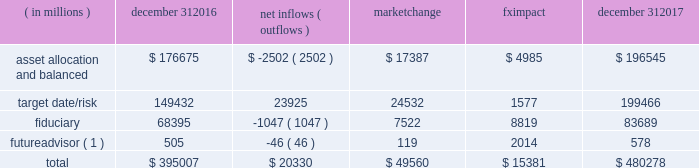Long-term product offerings include alpha-seeking active and index strategies .
Our alpha-seeking active strategies seek to earn attractive returns in excess of a market benchmark or performance hurdle while maintaining an appropriate risk profile , and leverage fundamental research and quantitative models to drive portfolio construction .
In contrast , index strategies seek to closely track the returns of a corresponding index , generally by investing in substantially the same underlying securities within the index or in a subset of those securities selected to approximate a similar risk and return profile of the index .
Index strategies include both our non-etf index products and ishares etfs .
Although many clients use both alpha-seeking active and index strategies , the application of these strategies may differ .
For example , clients may use index products to gain exposure to a market or asset class , or may use a combination of index strategies to target active returns .
In addition , institutional non-etf index assignments tend to be very large ( multi-billion dollars ) and typically reflect low fee rates .
Net flows in institutional index products generally have a small impact on blackrock 2019s revenues and earnings .
Equity year-end 2017 equity aum totaled $ 3.372 trillion , reflecting net inflows of $ 130.1 billion .
Net inflows included $ 174.4 billion into ishares etfs , driven by net inflows into core funds and broad developed and emerging market equities , partially offset by non-etf index and active net outflows of $ 25.7 billion and $ 18.5 billion , respectively .
Blackrock 2019s effective fee rates fluctuate due to changes in aum mix .
Approximately half of blackrock 2019s equity aum is tied to international markets , including emerging markets , which tend to have higher fee rates than u.s .
Equity strategies .
Accordingly , fluctuations in international equity markets , which may not consistently move in tandem with u.s .
Markets , have a greater impact on blackrock 2019s equity revenues and effective fee rate .
Fixed income fixed income aum ended 2017 at $ 1.855 trillion , reflecting net inflows of $ 178.8 billion .
In 2017 , active net inflows of $ 21.5 billion were diversified across fixed income offerings , and included strong inflows into municipal , unconstrained and total return bond funds .
Ishares etfs net inflows of $ 67.5 billion were led by flows into core , corporate and treasury bond funds .
Non-etf index net inflows of $ 89.8 billion were driven by demand for liability-driven investment solutions .
Multi-asset blackrock 2019s multi-asset team manages a variety of balanced funds and bespoke mandates for a diversified client base that leverages our broad investment expertise in global equities , bonds , currencies and commodities , and our extensive risk management capabilities .
Investment solutions might include a combination of long-only portfolios and alternative investments as well as tactical asset allocation overlays .
Component changes in multi-asset aum for 2017 are presented below .
( in millions ) december 31 , net inflows ( outflows ) market change impact december 31 .
( 1 ) futureadvisor amounts do not include aum held in ishares etfs .
Multi-asset net inflows reflected ongoing institutional demand for our solutions-based advice with $ 18.9 billion of net inflows coming from institutional clients .
Defined contribution plans of institutional clients remained a significant driver of flows , and contributed $ 20.8 billion to institutional multi-asset net inflows in 2017 , primarily into target date and target risk product offerings .
Retail net inflows of $ 1.1 billion reflected demand for our multi-asset income fund family , which raised $ 5.8 billion in 2017 .
The company 2019s multi-asset strategies include the following : 2022 asset allocation and balanced products represented 41% ( 41 % ) of multi-asset aum at year-end .
These strategies combine equity , fixed income and alternative components for investors seeking a tailored solution relative to a specific benchmark and within a risk budget .
In certain cases , these strategies seek to minimize downside risk through diversification , derivatives strategies and tactical asset allocation decisions .
Flagship products in this category include our global allocation and multi-asset income fund families .
2022 target date and target risk products grew 16% ( 16 % ) organically in 2017 , with net inflows of $ 23.9 billion .
Institutional investors represented 93% ( 93 % ) of target date and target risk aum , with defined contribution plans accounting for 87% ( 87 % ) of aum .
Flows were driven by defined contribution investments in our lifepath offerings .
Lifepath products utilize a proprietary active asset allocation overlay model that seeks to balance risk and return over an investment horizon based on the investor 2019s expected retirement timing .
Underlying investments are primarily index products .
2022 fiduciary management services are complex mandates in which pension plan sponsors or endowments and foundations retain blackrock to assume responsibility for some or all aspects of investment management .
These customized services require strong partnership with the clients 2019 investment staff and trustees in order to tailor investment strategies to meet client-specific risk budgets and return objectives. .
What was the value of the total fximpact and market change impact ? in million $ .? 
Computations: (49560 + 15381)
Answer: 64941.0. 